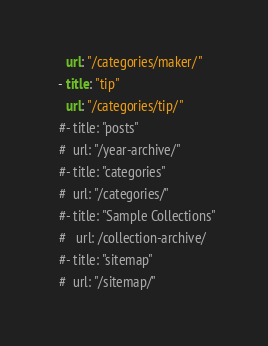Convert code to text. <code><loc_0><loc_0><loc_500><loc_500><_YAML_>    url: "/categories/maker/"
  - title: "tip"
    url: "/categories/tip/"
  #- title: "posts"
  #  url: "/year-archive/"
  #- title: "categories"
  #  url: "/categories/"
  #- title: "Sample Collections"
  #   url: /collection-archive/
  #- title: "sitemap"
  #  url: "/sitemap/"
</code> 